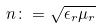<formula> <loc_0><loc_0><loc_500><loc_500>n \colon = \sqrt { \epsilon _ { r } \mu _ { r } }</formula> 